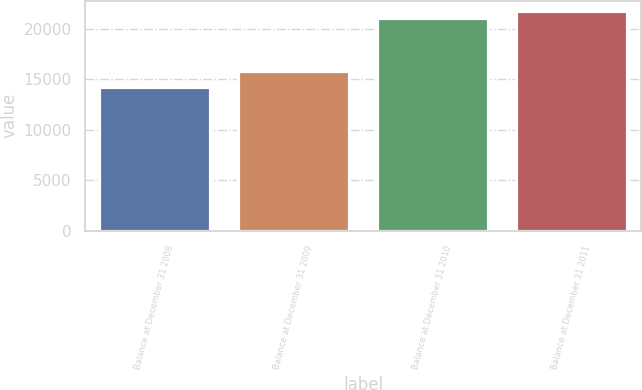Convert chart. <chart><loc_0><loc_0><loc_500><loc_500><bar_chart><fcel>Balance at December 31 2008<fcel>Balance at December 31 2009<fcel>Balance at December 31 2010<fcel>Balance at December 31 2011<nl><fcel>14248<fcel>15815<fcel>21041<fcel>21730.6<nl></chart> 